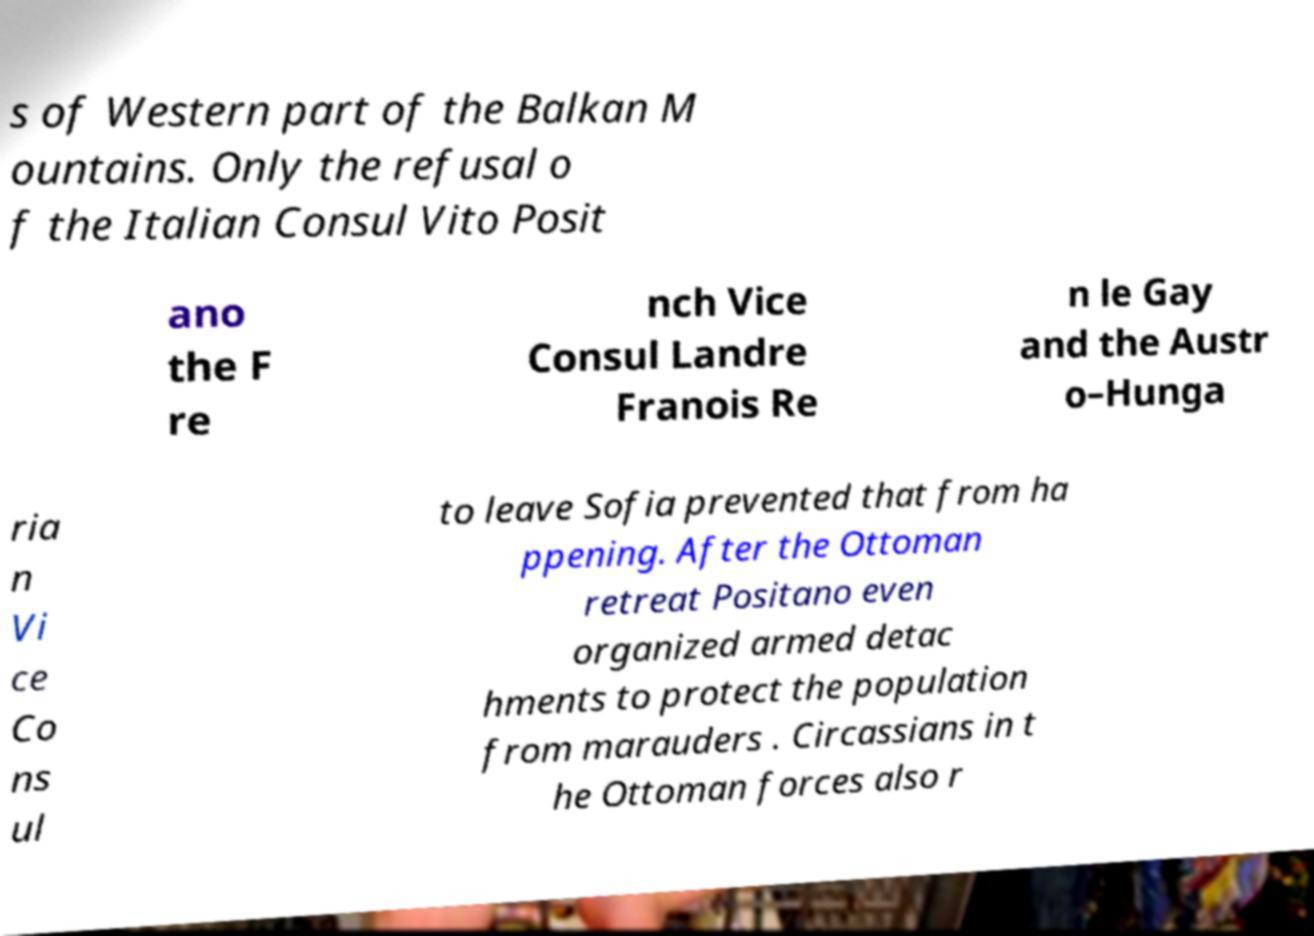Can you accurately transcribe the text from the provided image for me? s of Western part of the Balkan M ountains. Only the refusal o f the Italian Consul Vito Posit ano the F re nch Vice Consul Landre Franois Re n le Gay and the Austr o–Hunga ria n Vi ce Co ns ul to leave Sofia prevented that from ha ppening. After the Ottoman retreat Positano even organized armed detac hments to protect the population from marauders . Circassians in t he Ottoman forces also r 